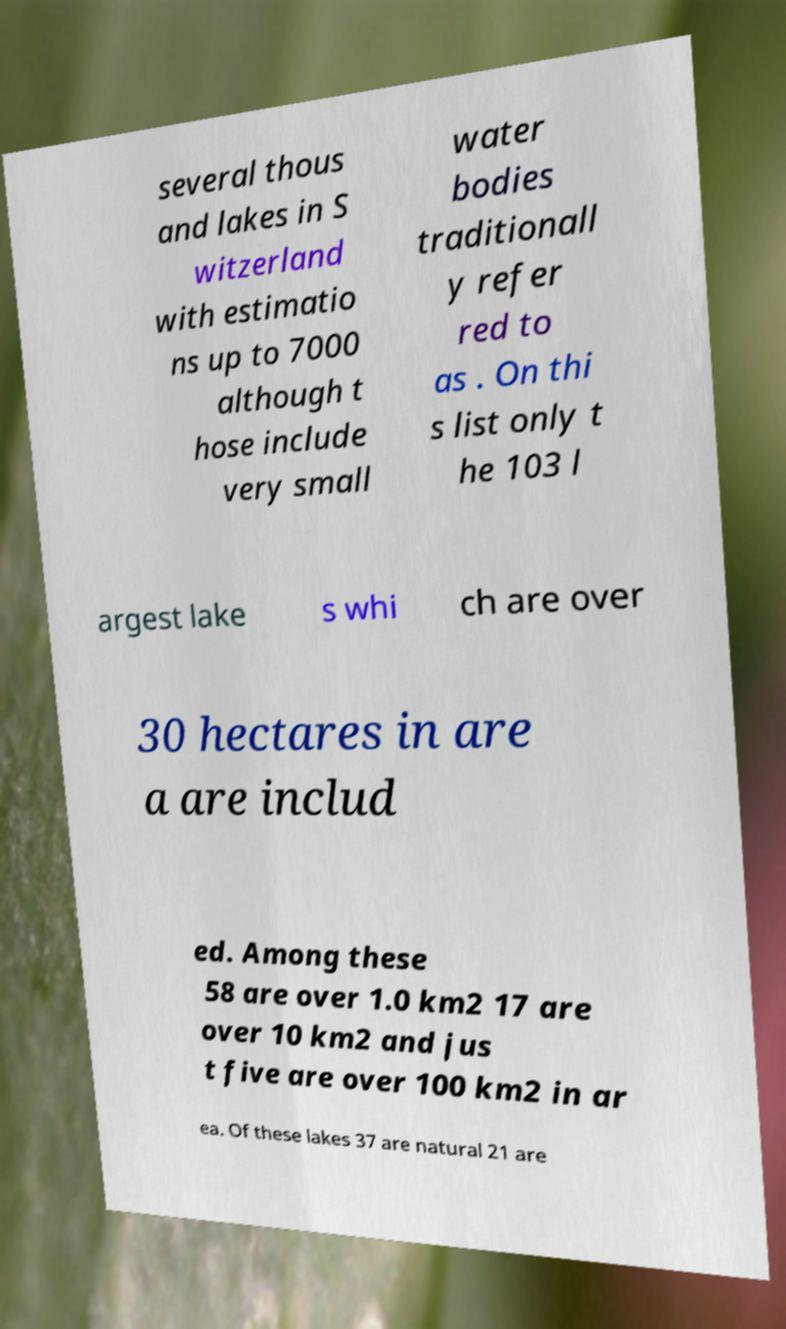I need the written content from this picture converted into text. Can you do that? several thous and lakes in S witzerland with estimatio ns up to 7000 although t hose include very small water bodies traditionall y refer red to as . On thi s list only t he 103 l argest lake s whi ch are over 30 hectares in are a are includ ed. Among these 58 are over 1.0 km2 17 are over 10 km2 and jus t five are over 100 km2 in ar ea. Of these lakes 37 are natural 21 are 